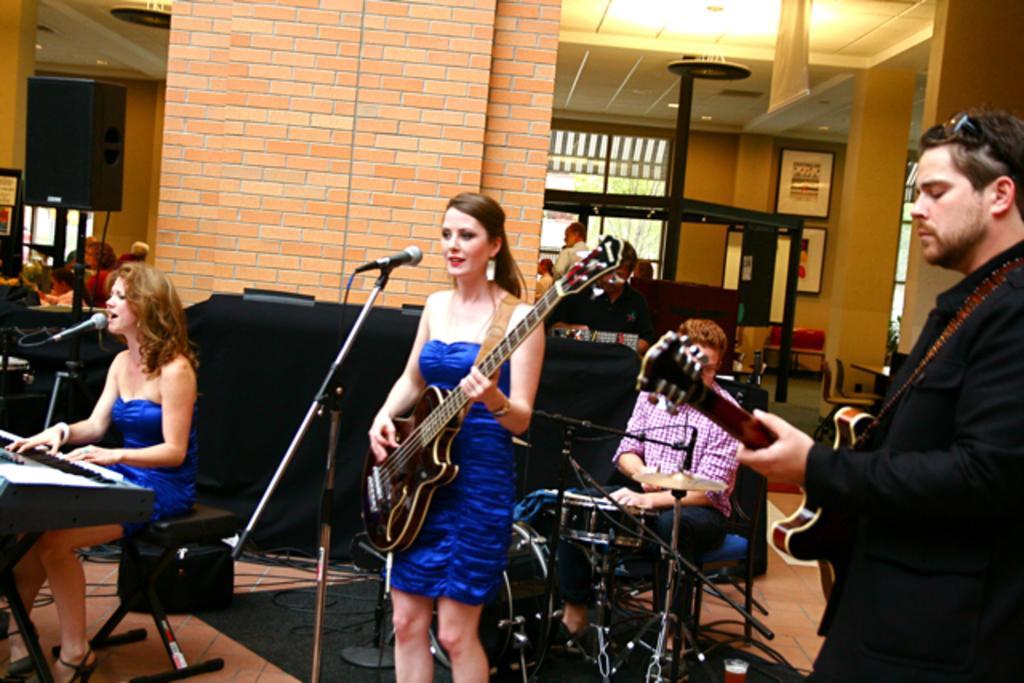In one or two sentences, can you explain what this image depicts? In this picture there is a woman wearing a blue dress is sitting on the chair and playing piano. She is singing on mic. There is other woman who is playing guitar. There is a man wearing pink shirt is sitting on the chair and holding a drum. There is a man wearing a black jacket is holding a guitar. There are also few people at the background. There is a light. There is a loudspeaker. there are frames on the wall. There is a tree at the background. There is a green carpet. 